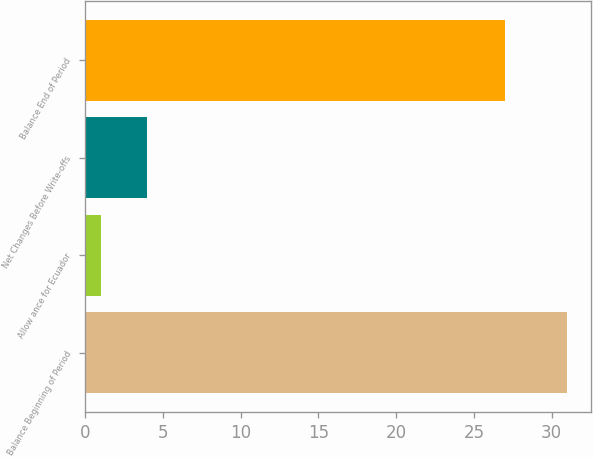<chart> <loc_0><loc_0><loc_500><loc_500><bar_chart><fcel>Balance Beginning of Period<fcel>Allow ance for Ecuador<fcel>Net Changes Before Write-offs<fcel>Balance End of Period<nl><fcel>31<fcel>1<fcel>4<fcel>27<nl></chart> 